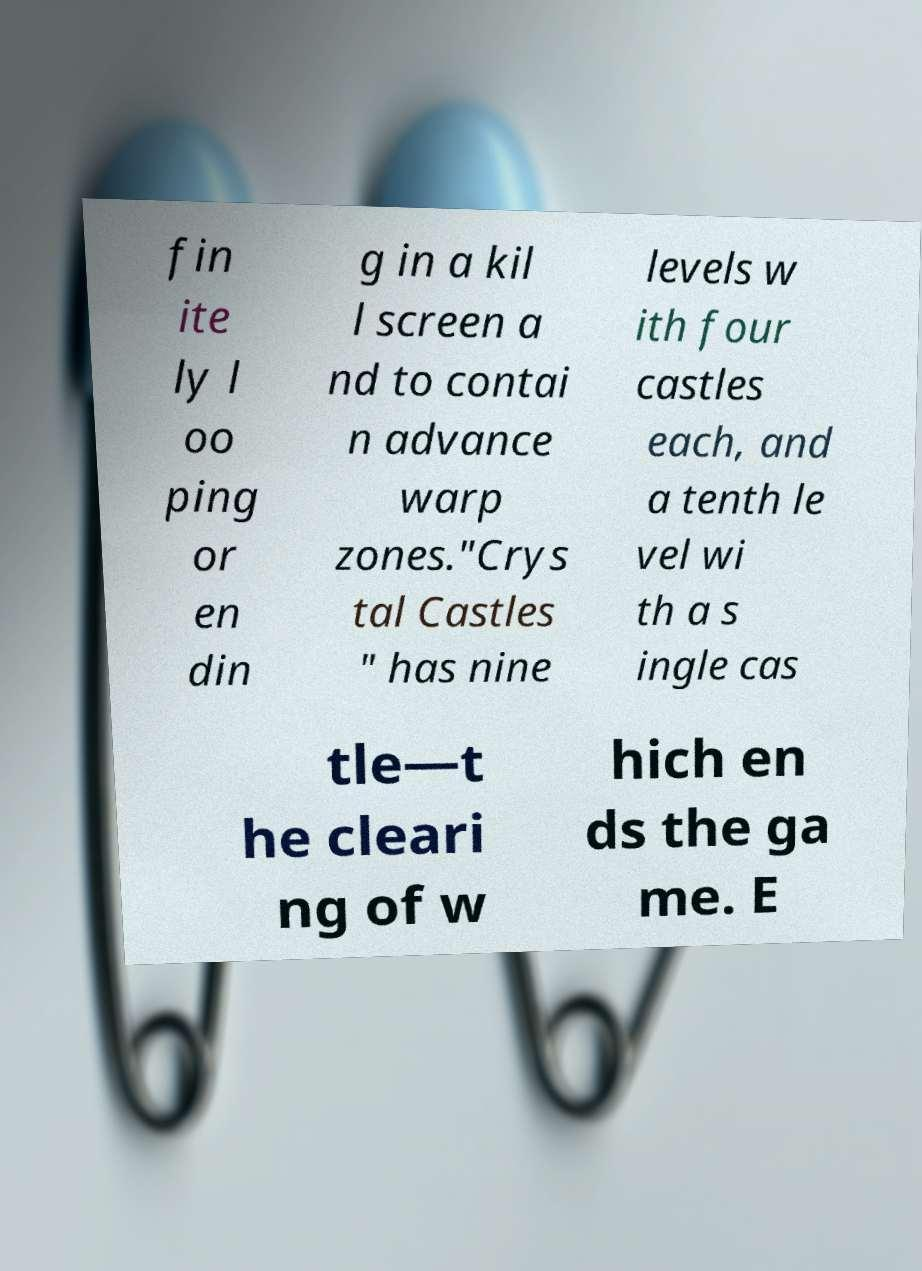I need the written content from this picture converted into text. Can you do that? fin ite ly l oo ping or en din g in a kil l screen a nd to contai n advance warp zones."Crys tal Castles " has nine levels w ith four castles each, and a tenth le vel wi th a s ingle cas tle—t he cleari ng of w hich en ds the ga me. E 